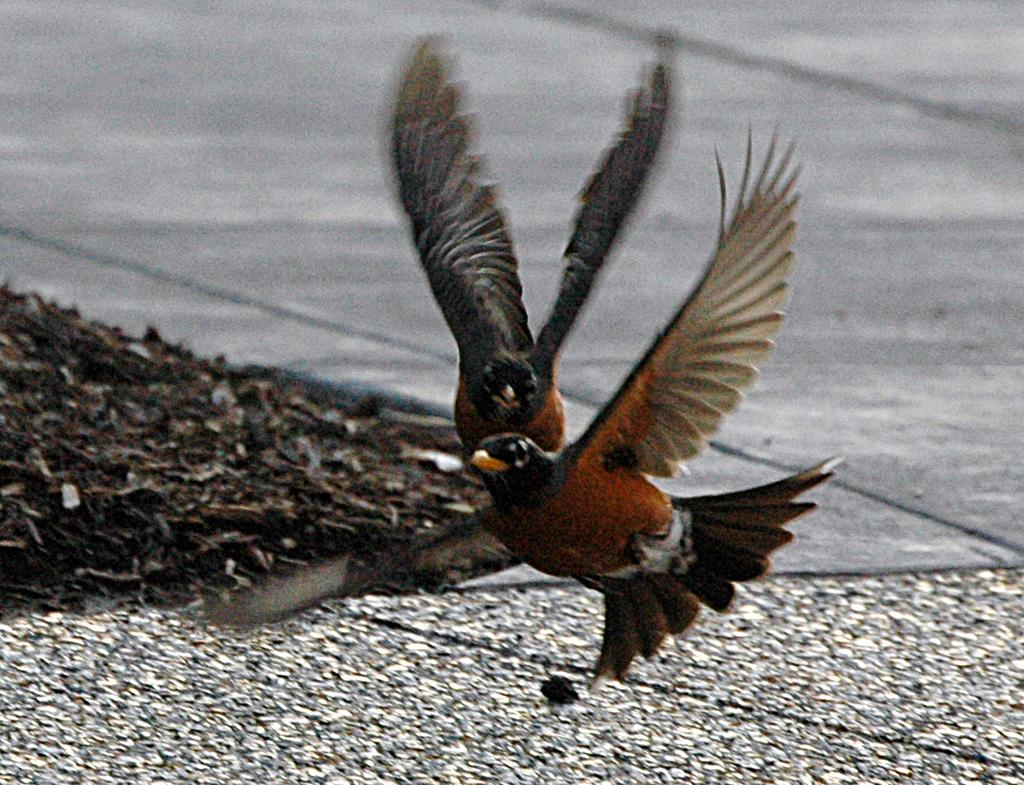What type of animals are in the image? There are two brown color birds in the image. What are the birds doing in the image? The birds are flying. What is located at the bottom of the image? There is a road at the bottom of the image. What year is depicted in the image? There is no indication of a specific year in the image. 